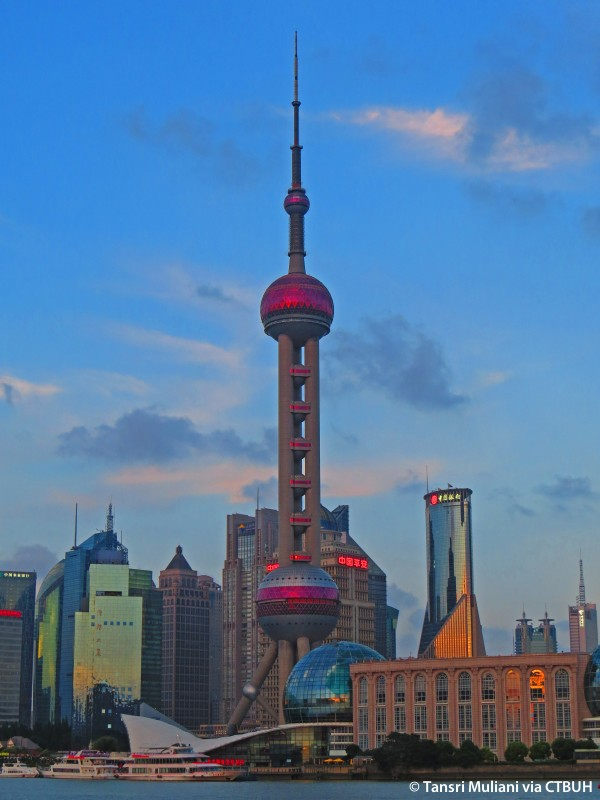Imagine this tower in a future setting. How might it look? In a future setting, the Oriental Pearl Tower could be outfitted with advanced technologies that enhance its visual appeal and functionality. Imagine the tower covered in adaptive smart glass that changes colors and patterns in response to environmental conditions or special events. Holographic projections could be integrated, displaying dazzling light shows and interactive information for visitors. The surrounding skyscrapers could be connected with Skybridges, creating an interconnected network of buildings that exemplify futuristic urban planning. Drone ports and vertical gardens could be added, blending advanced technology with sustainable practices. Overall, the future Oriental Pearl Tower would stand as a beacon of innovation and sustainability, merging cutting-edge technology with visionary design. Could you create a scenario where the tower plays a role in a sci-fi story? In a futuristic sci-fi story, the Oriental Pearl Tower could serve as the headquarters for an elite team of inter-galactic peacekeepers. Equipped with advanced communication systems and teleportation technology, the tower acts as the central command center for coordinating missions across the galaxy. Its observation decks are transformed into monitoring stations, allowing the team to keep an eye on potential threats and provide real-time assistance to distant planets. The tower's unique architecture becomes a landmark of hope and security, standing tall amidst a city that serves as the gateway to the stars. As the story unfolds, the team faces a looming cosmic threat, requiring them to harness the full potential of their technologically advanced headquarters to save the universe. 